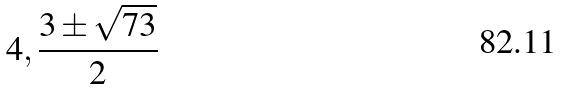<formula> <loc_0><loc_0><loc_500><loc_500>4 , \frac { 3 \pm \sqrt { 7 3 } } { 2 }</formula> 